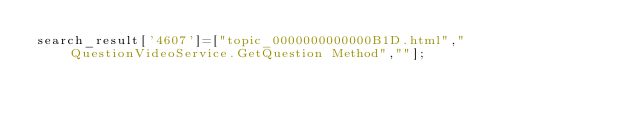Convert code to text. <code><loc_0><loc_0><loc_500><loc_500><_JavaScript_>search_result['4607']=["topic_0000000000000B1D.html","QuestionVideoService.GetQuestion Method",""];</code> 